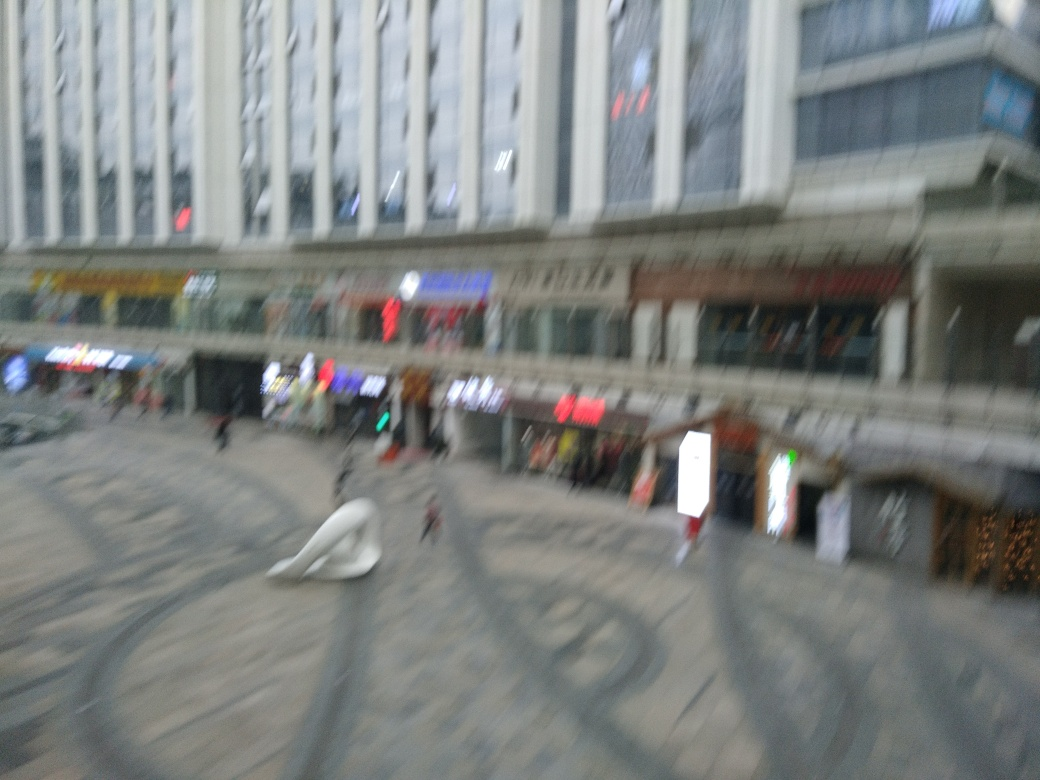What can we infer about the location from the image? The image suggests an urban commercial area with shops and restaurants, likely a downtown or central business district. The diversity in signage and the presence of what appears to be commercial advertising point towards a bustling city environment. 